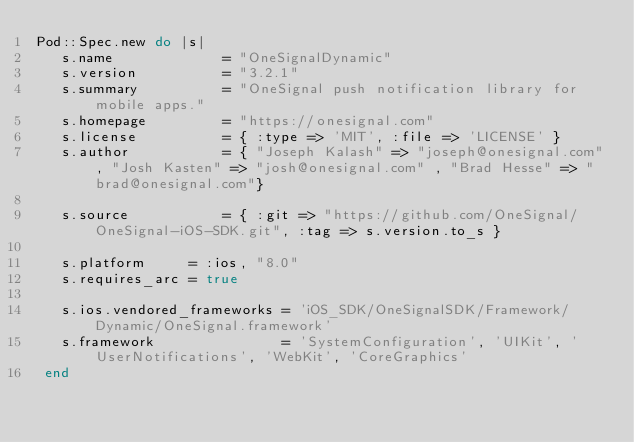Convert code to text. <code><loc_0><loc_0><loc_500><loc_500><_Ruby_>Pod::Spec.new do |s|
   s.name             = "OneSignalDynamic"
   s.version          = "3.2.1"
   s.summary          = "OneSignal push notification library for mobile apps."
   s.homepage         = "https://onesignal.com"
   s.license          = { :type => 'MIT', :file => 'LICENSE' }
   s.author           = { "Joseph Kalash" => "joseph@onesignal.com", "Josh Kasten" => "josh@onesignal.com" , "Brad Hesse" => "brad@onesignal.com"}
   
   s.source           = { :git => "https://github.com/OneSignal/OneSignal-iOS-SDK.git", :tag => s.version.to_s }
   
   s.platform     = :ios, "8.0"
   s.requires_arc = true
   
   s.ios.vendored_frameworks = 'iOS_SDK/OneSignalSDK/Framework/Dynamic/OneSignal.framework'
   s.framework               = 'SystemConfiguration', 'UIKit', 'UserNotifications', 'WebKit', 'CoreGraphics'
 end
 </code> 